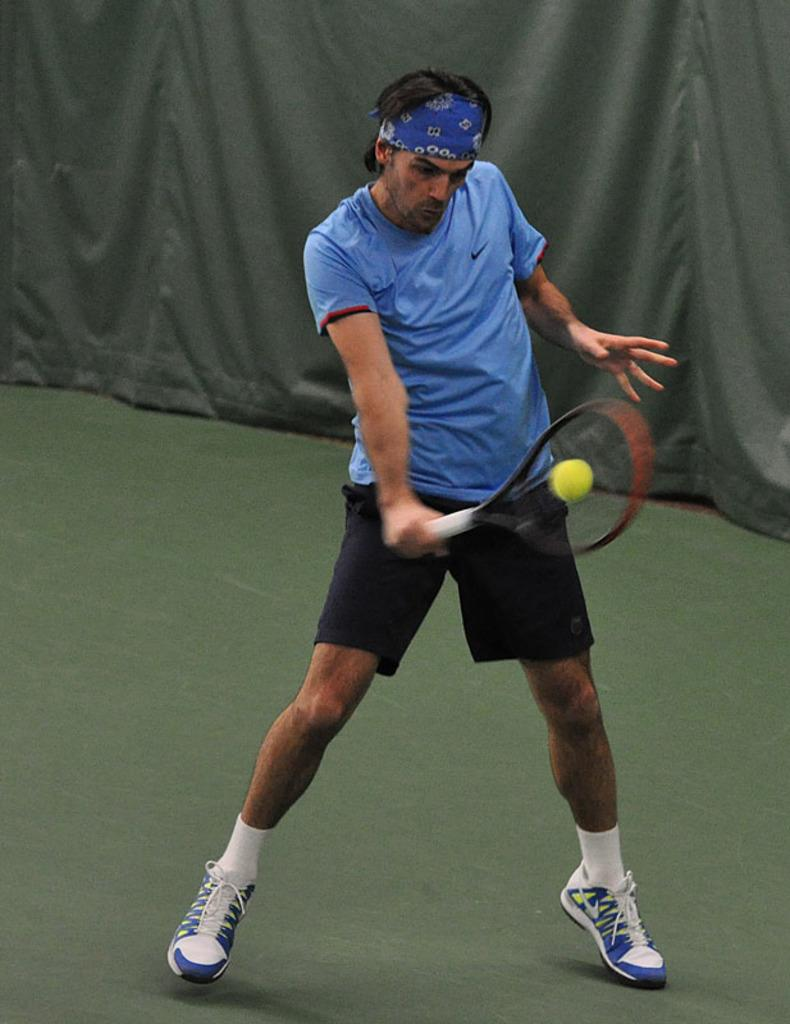Who is present in the image? There is a man in the image. What is the man holding in the image? The man is holding a shuttle racket. What is the man doing with the shuttle racket? The man is hitting a ball with the shuttle racket. What type of cloth is the man using to cover the ball in the image? There is no cloth present in the image, nor is the man covering the ball. 